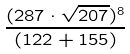Convert formula to latex. <formula><loc_0><loc_0><loc_500><loc_500>\frac { ( 2 8 7 \cdot \sqrt { 2 0 7 } ) ^ { 8 } } { ( 1 2 2 + 1 5 5 ) }</formula> 